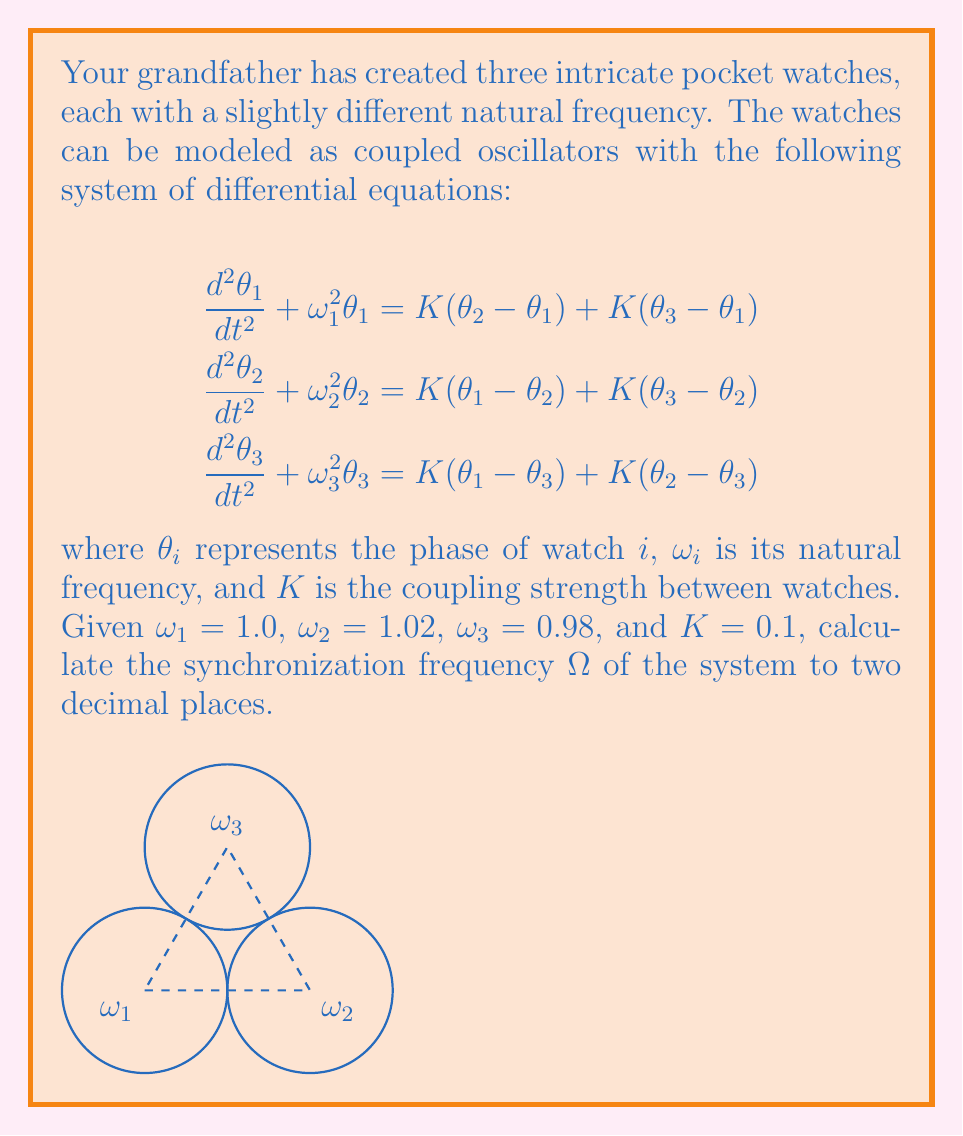Can you solve this math problem? To find the synchronization frequency of the coupled oscillator system, we'll follow these steps:

1) The synchronization frequency $\Omega$ for a system of coupled oscillators is approximately the average of their natural frequencies:

   $$\Omega \approx \frac{1}{N}\sum_{i=1}^N \omega_i$$

   where $N$ is the number of oscillators.

2) In this case, we have three watches, so $N = 3$:

   $$\Omega \approx \frac{1}{3}(\omega_1 + \omega_2 + \omega_3)$$

3) Substituting the given values:

   $$\Omega \approx \frac{1}{3}(1.0 + 1.02 + 0.98)$$

4) Calculating:

   $$\Omega \approx \frac{1}{3}(3.0) = 1.0$$

5) Rounding to two decimal places:

   $$\Omega \approx 1.00$$

Note: This approximation is valid when the coupling strength $K$ is relatively small compared to the differences in natural frequencies, which is the case here.
Answer: $\Omega \approx 1.00$ 